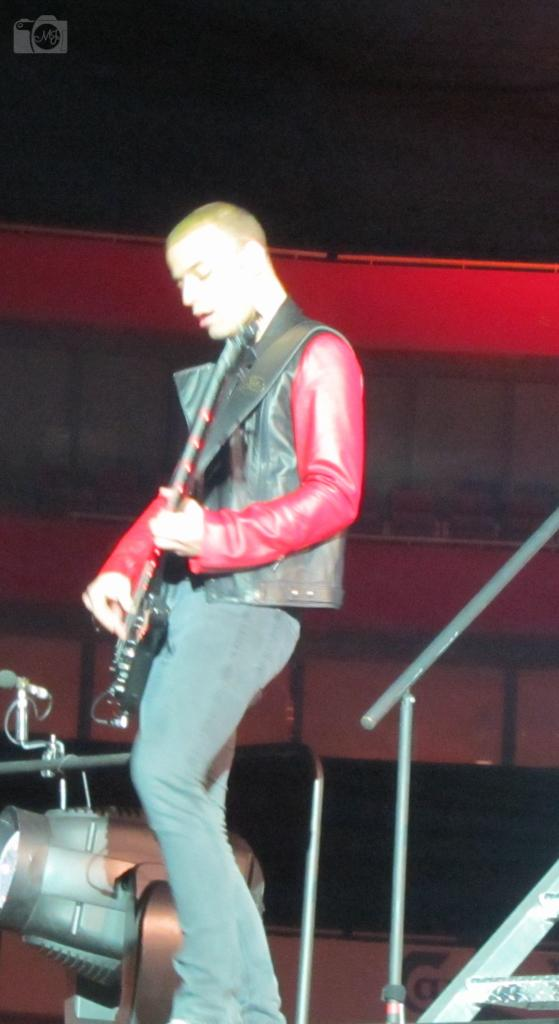What is the main subject of the image? The main subject of the image is a man. Where is the man located in the image? The man is standing on a stage. What is the man doing on the stage? The man is playing a guitar. What type of plastic material is being used as a guide for the man on the stage? There is no plastic material being used as a guide for the man on the stage in the image. 